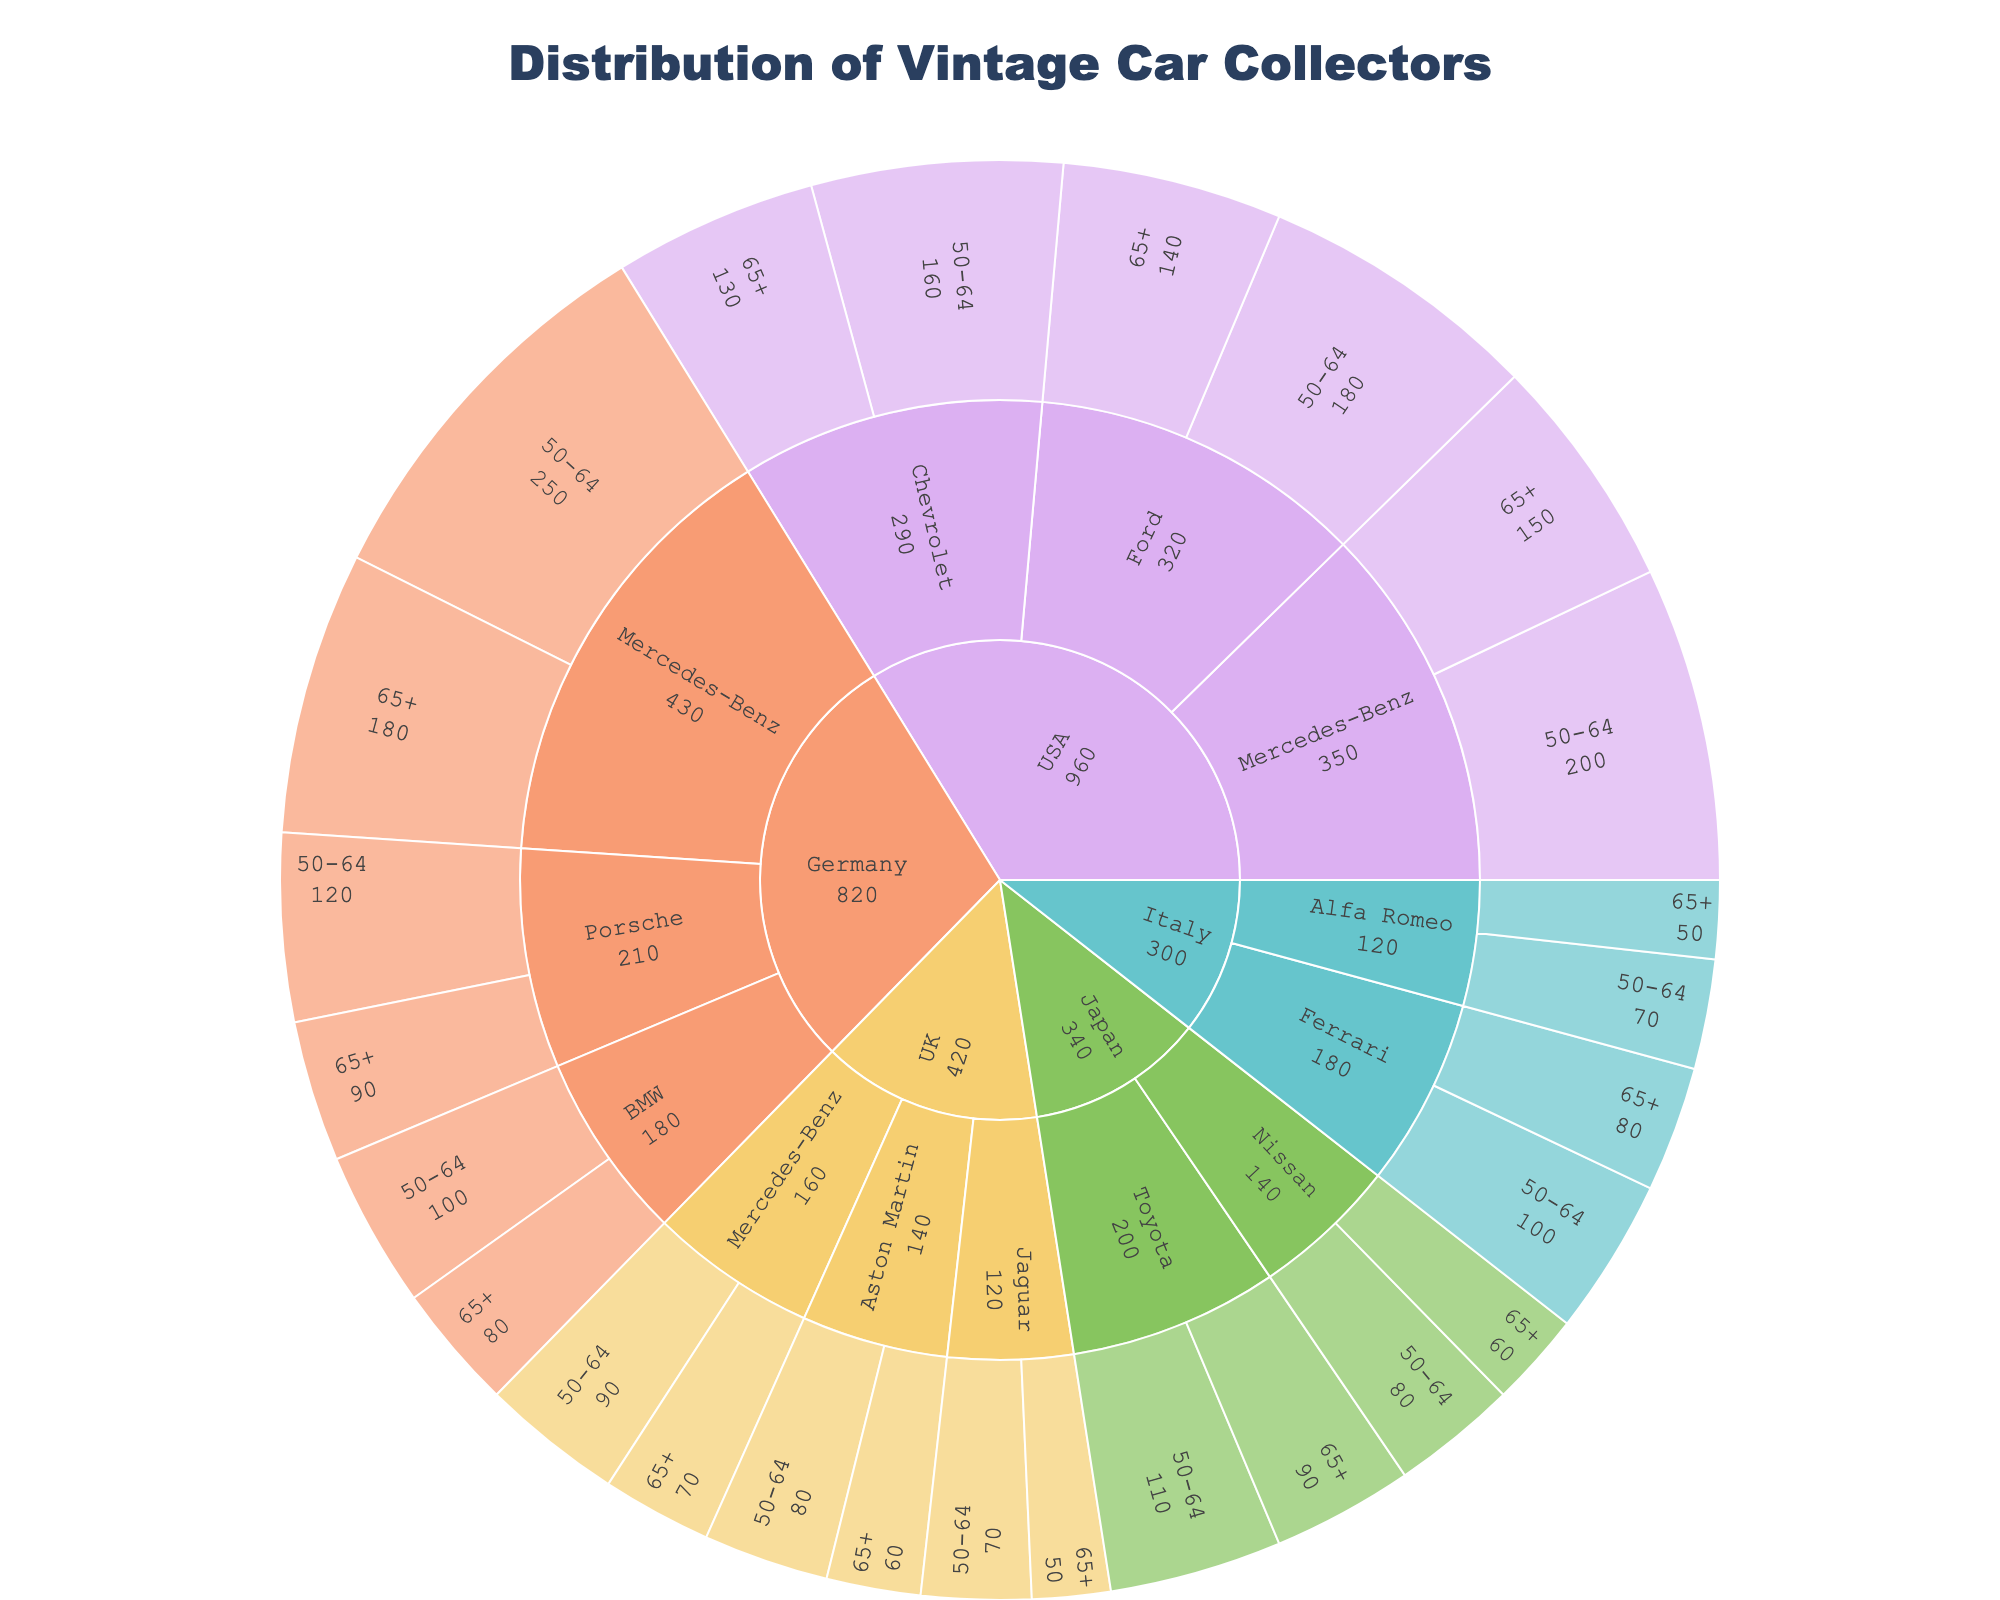what is the most common vintage car brand collected in Germany? By observing the sunburst plot, check the segment corresponding to Germany and identify the car brand with the highest combined value (sum of its age groups).
Answer: Mercedes-Benz with 430 collectors How many car collectors in total are there in the USA? Sum up the values for all brands and age groups under the USA segment. The values to add are 200 (50-64 for Mercedes-Benz) + 150 (65+ for Mercedes-Benz) + 180 (50-64 for Ford) + 140 (65+ for Ford) + 160 (50-64 for Chevrolet) + 130 (65+ for Chevrolet).
Answer: 960 Which country has the highest number of Mercedes-Benz collectors? Inspect the sunburst plot section by section and see which country has the largest value for Mercedes-Benz collectors. Germany has 430, USA has 350, and the UK has 160.
Answer: Germany What is the total number of vintage car collectors aged 65+ in Italy? Look at the Italy segment and sum the values for the 65+ age group across all brands. This includes 80 (Ferrari) + 50 (Alfa Romeo).
Answer: 130 Which age group has more Porsche collectors in Germany? Compare the values for the 50-64 and 65+ age groups under the Porsche brand in Germany. 50-64 has 120 collectors and 65+ has 90.
Answer: 50-64 How does the number of German Ferrari collectors compare to the number of Italian Ferrari collectors? Check the sunburst plot for Germany and Italy under Ferrari. Germany has no collectors for Ferrari, while Italy has 100 (50-64) + 80 (65+).
Answer: Italy has more Ferrari collectors, 180 in total What percentage of vintage car collectors in Japan prefer Nissan? Calculate the total number of collectors in Japan (110 (Toyota 50-64) + 90 (Toyota 65+) + 80 (Nissan 50-64) + 60 (Nissan 65+)) and the number of Nissan collectors (80 + 60). Percentage = (Nissan collectors / Total collectors) * 100.
Answer: 41.67% Is the number of Mercedes-Benz collectors in the UK greater than the number of Jaguar collectors? Compare the values under the UK segment for Mercedes-Benz (90 (50-64) + 70 (65+)) and Jaguar (70 (50-64) + 50 (65+)).
Answer: Yes, 160 vs. 120 How many more vintage car collectors are there in Germany compared to Japan? Sum up the values for all brands and age groups in Germany and Japan and subtract Japan's total from Germany's total. Germany's total = 820, Japan's total = 340.
Answer: 480 